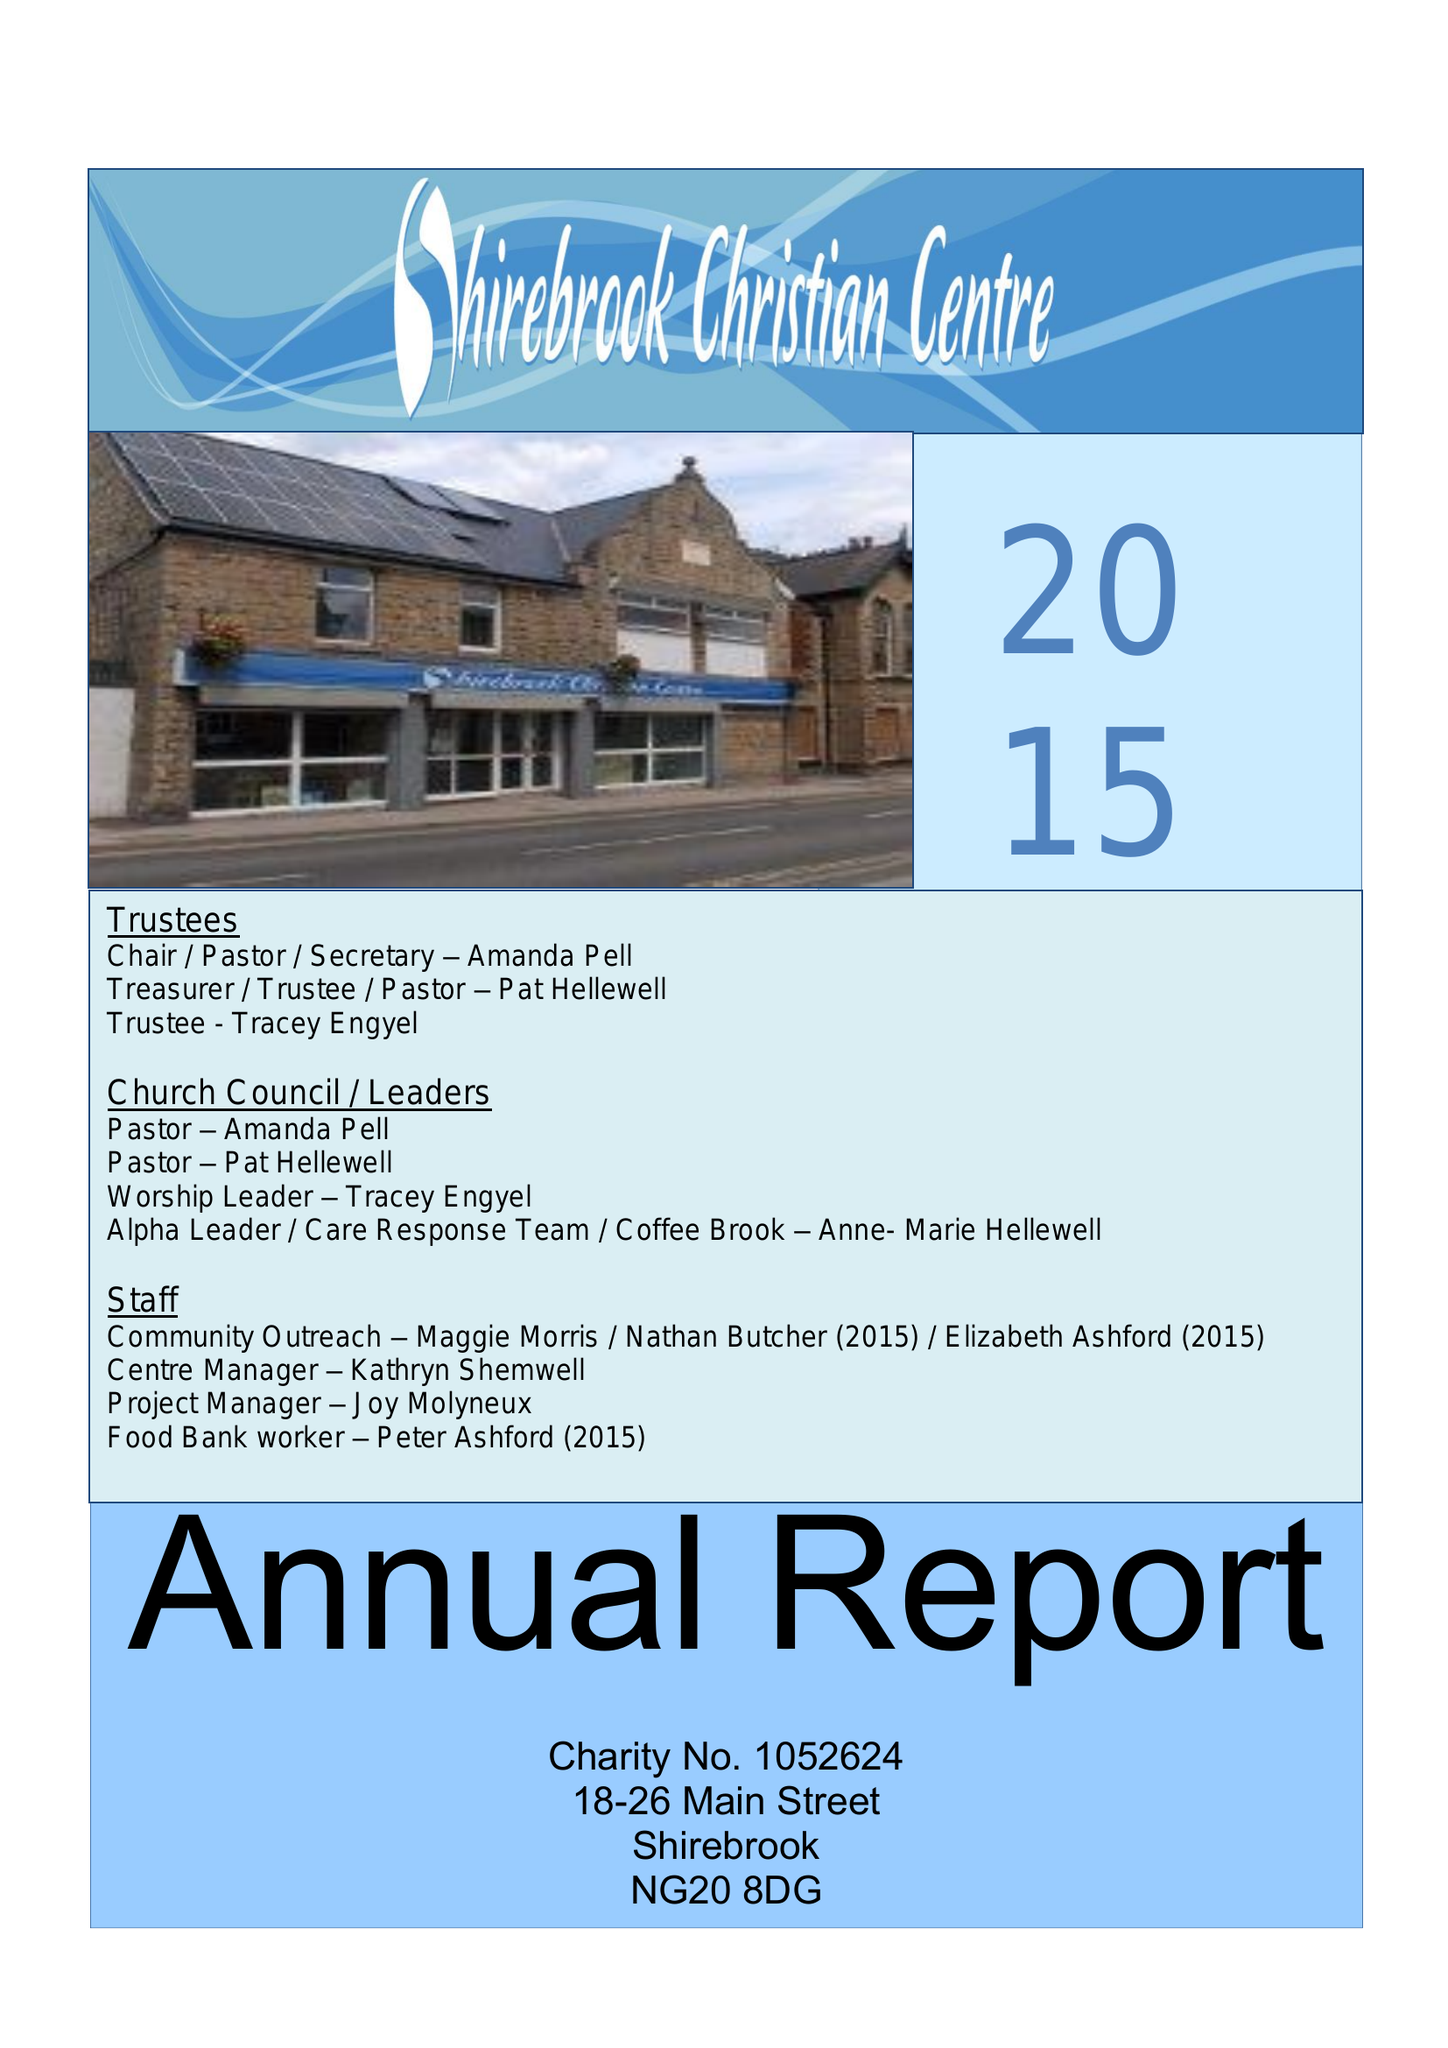What is the value for the spending_annually_in_british_pounds?
Answer the question using a single word or phrase. 88393.00 